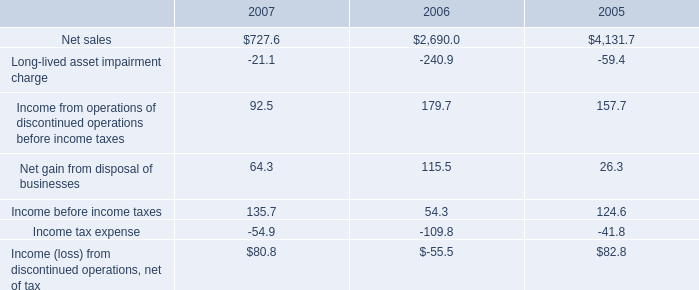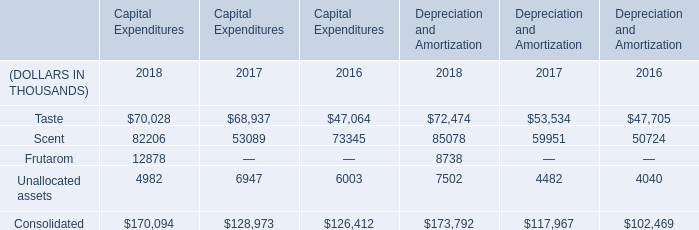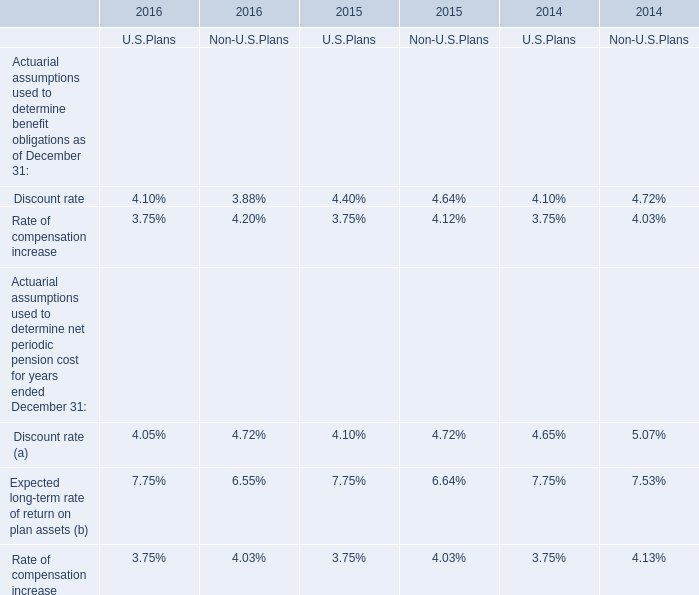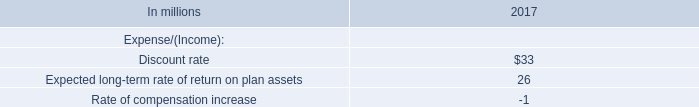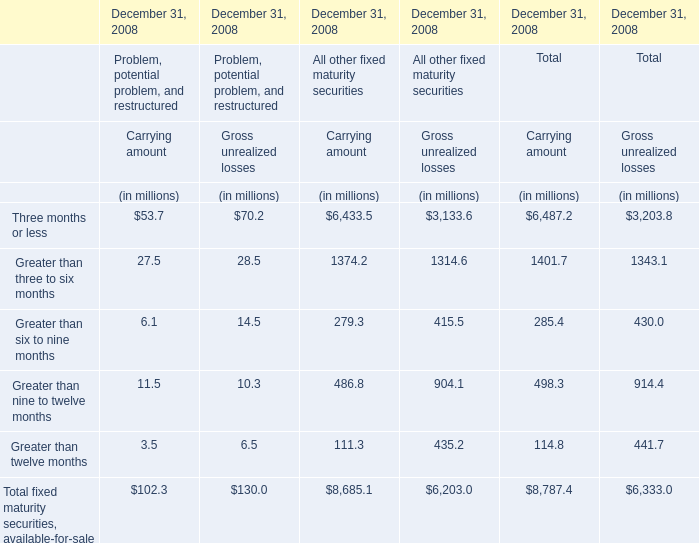What's the sum of Net sales of 2005, Frutarom of Depreciation and Amortization 2018, and Scent of Capital Expenditures 2017 ? 
Computations: ((4131.7 + 8738.0) + 53089.0)
Answer: 65958.7. 